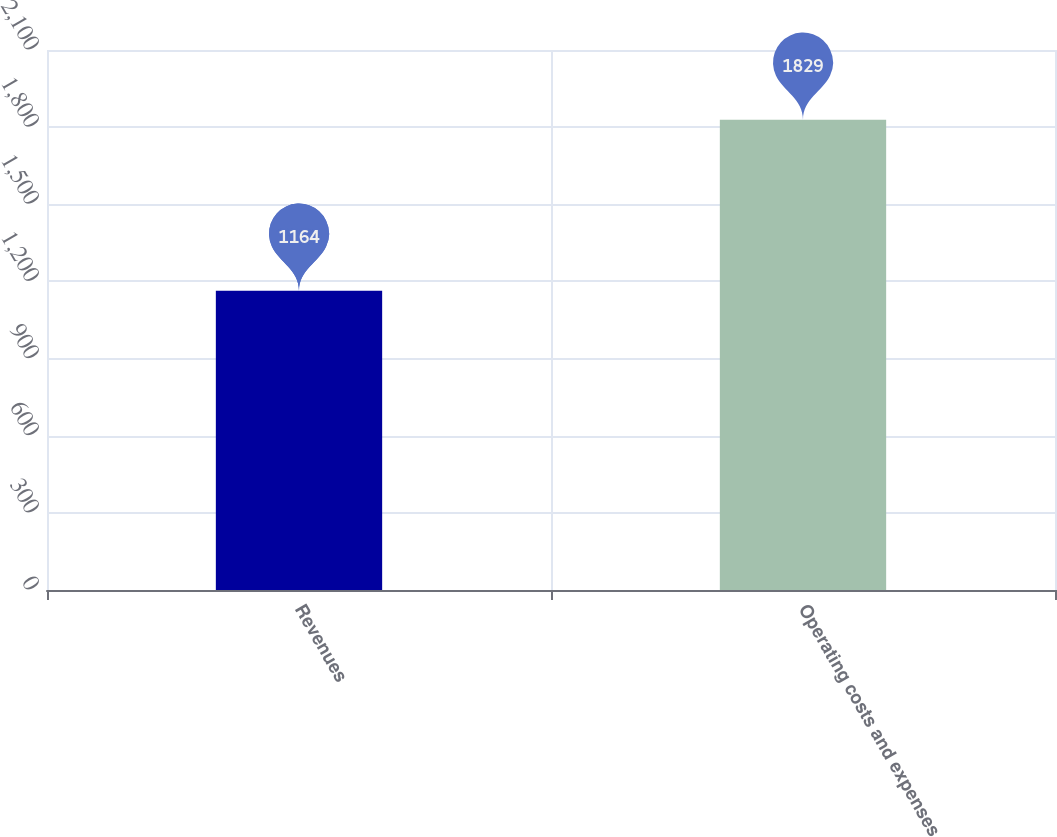Convert chart. <chart><loc_0><loc_0><loc_500><loc_500><bar_chart><fcel>Revenues<fcel>Operating costs and expenses<nl><fcel>1164<fcel>1829<nl></chart> 